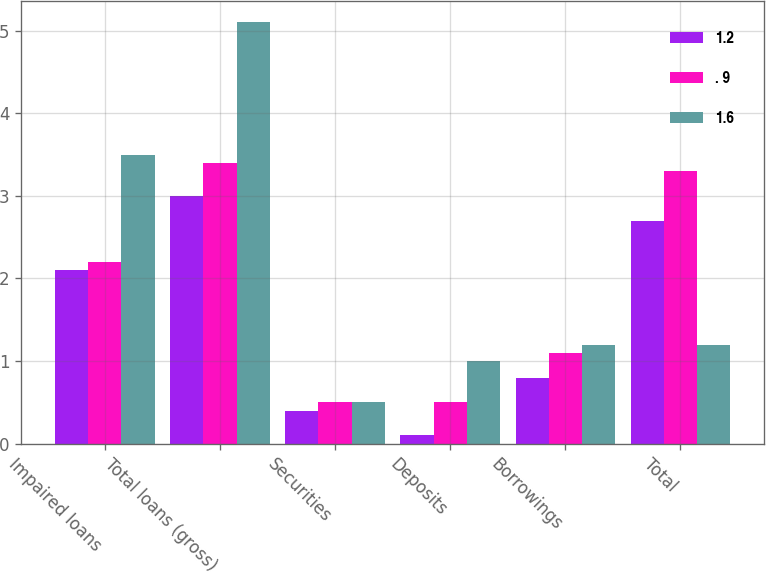<chart> <loc_0><loc_0><loc_500><loc_500><stacked_bar_chart><ecel><fcel>Impaired loans<fcel>Total loans (gross)<fcel>Securities<fcel>Deposits<fcel>Borrowings<fcel>Total<nl><fcel>1.2<fcel>2.1<fcel>3<fcel>0.4<fcel>0.1<fcel>0.8<fcel>2.7<nl><fcel>. 9<fcel>2.2<fcel>3.4<fcel>0.5<fcel>0.5<fcel>1.1<fcel>3.3<nl><fcel>1.6<fcel>3.5<fcel>5.1<fcel>0.5<fcel>1<fcel>1.2<fcel>1.2<nl></chart> 